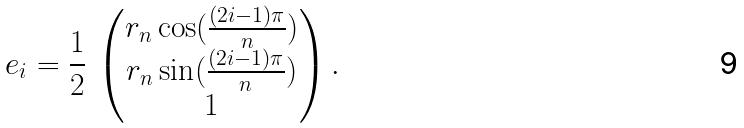Convert formula to latex. <formula><loc_0><loc_0><loc_500><loc_500>e _ { i } = \frac { 1 } { 2 } \, \begin{pmatrix} r _ { n } \cos ( \frac { ( 2 i - 1 ) \pi } { n } ) \\ r _ { n } \sin ( \frac { ( 2 i - 1 ) \pi } { n } ) \\ 1 \end{pmatrix} .</formula> 